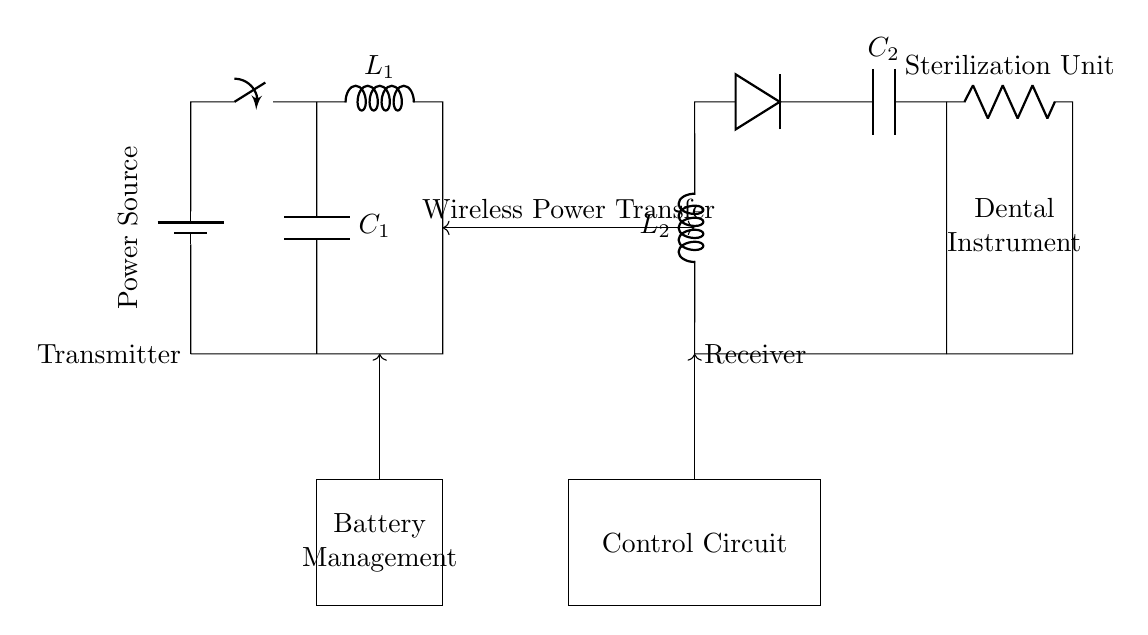What is the function of the control circuit? The control circuit manages the power flow to the sterilization unit and ensures proper operation by controlling the wireless power transfer.
Answer: Control What type of load is connected in this circuit? The load connected to the circuit is a sterilization unit, indicated clearly by the labeling in the circuit diagram.
Answer: Sterilization Unit How many components are used in the transmitter section? The transmitter section includes a battery, a switch, an inductor labeled L1, and a capacitor labeled C1, totaling four components.
Answer: Four What does the wireless power transfer indicate? The wireless power transfer is indicated by the two-way arrow in the center of the diagram, showing energy transfer from the transmitter to the receiver without physical connections.
Answer: Energy Transfer Which components are involved in the battery management? The battery management consists of a rectangular block drawn near the transmitter with an associated arrow indicating power flow which suggests a support role for the overall circuit.
Answer: Battery Management What type of inductor is used in the receiver? The inductor used in the receiver is labeled L2, indicating its role in the power conversion process from the received wireless energy into usable power for the load.
Answer: L2 Where is the power source located? The power source is denoted on the left side of the diagram with the label "Power Source," connected to the battery.
Answer: Power Source 